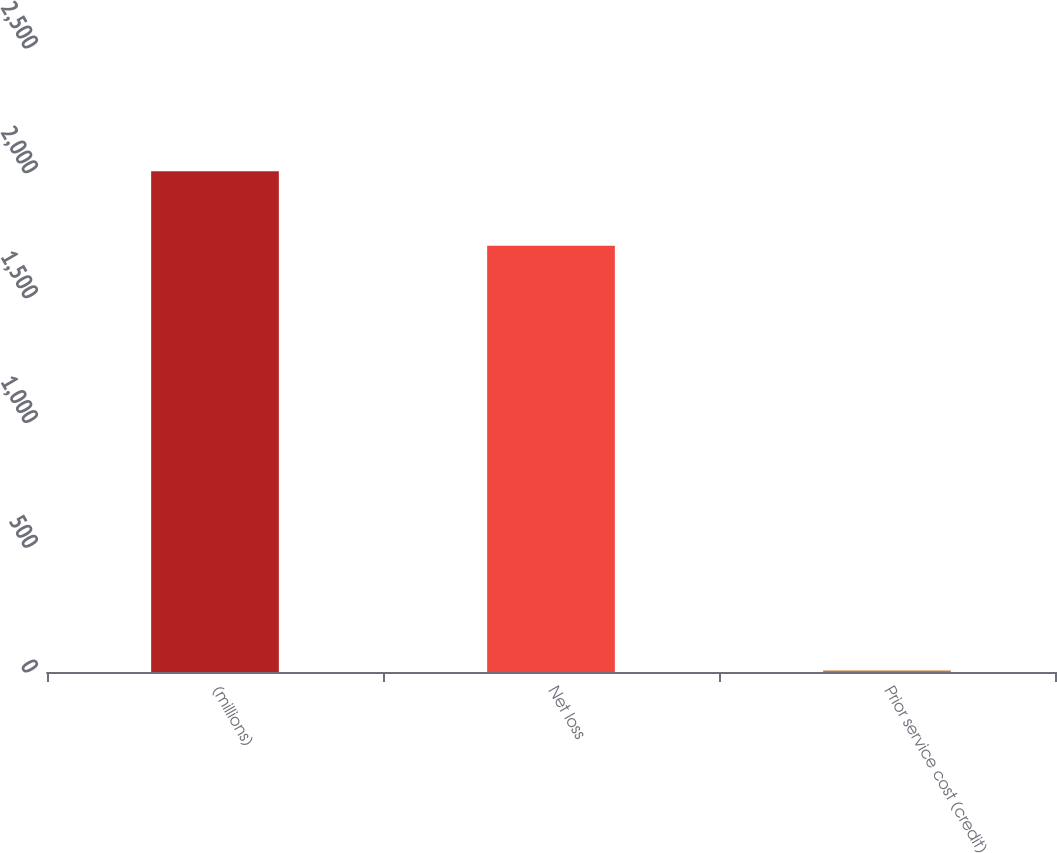Convert chart to OTSL. <chart><loc_0><loc_0><loc_500><loc_500><bar_chart><fcel>(millions)<fcel>Net loss<fcel>Prior service cost (credit)<nl><fcel>2006<fcel>1708<fcel>6<nl></chart> 